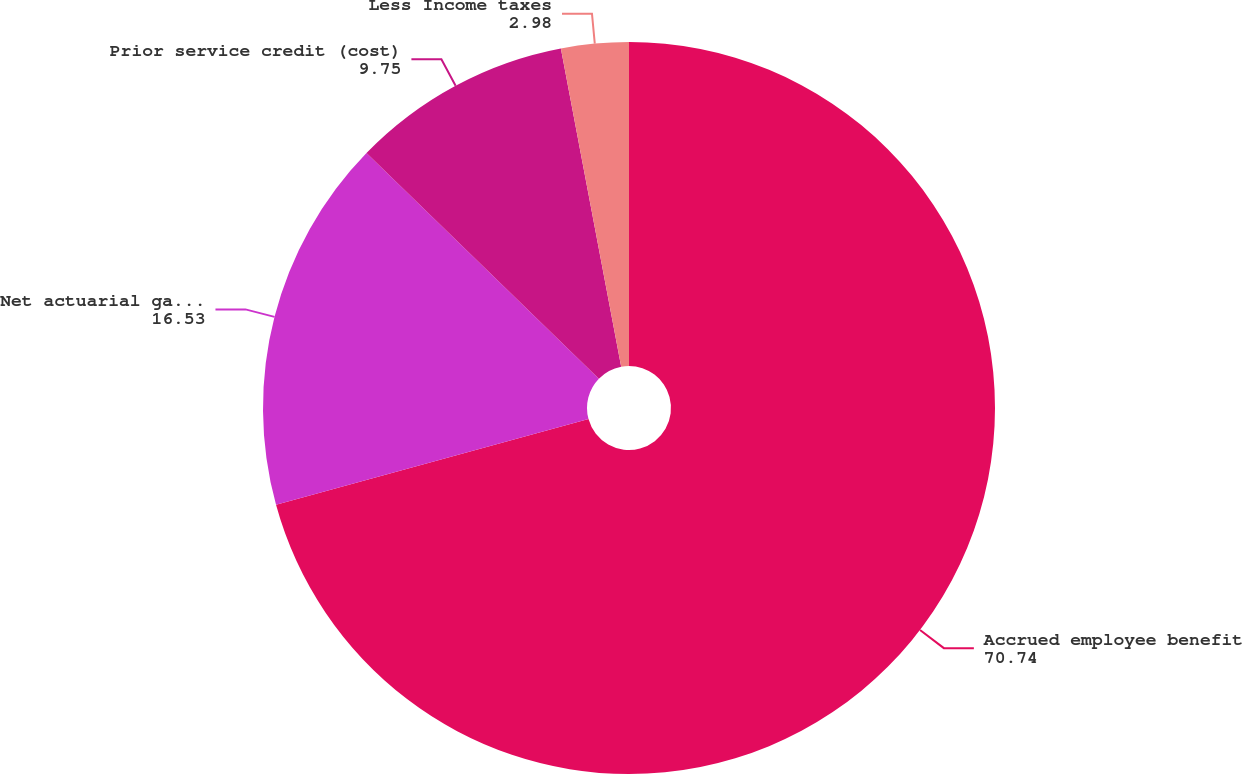Convert chart to OTSL. <chart><loc_0><loc_0><loc_500><loc_500><pie_chart><fcel>Accrued employee benefit<fcel>Net actuarial gain (loss)<fcel>Prior service credit (cost)<fcel>Less Income taxes<nl><fcel>70.74%<fcel>16.53%<fcel>9.75%<fcel>2.98%<nl></chart> 